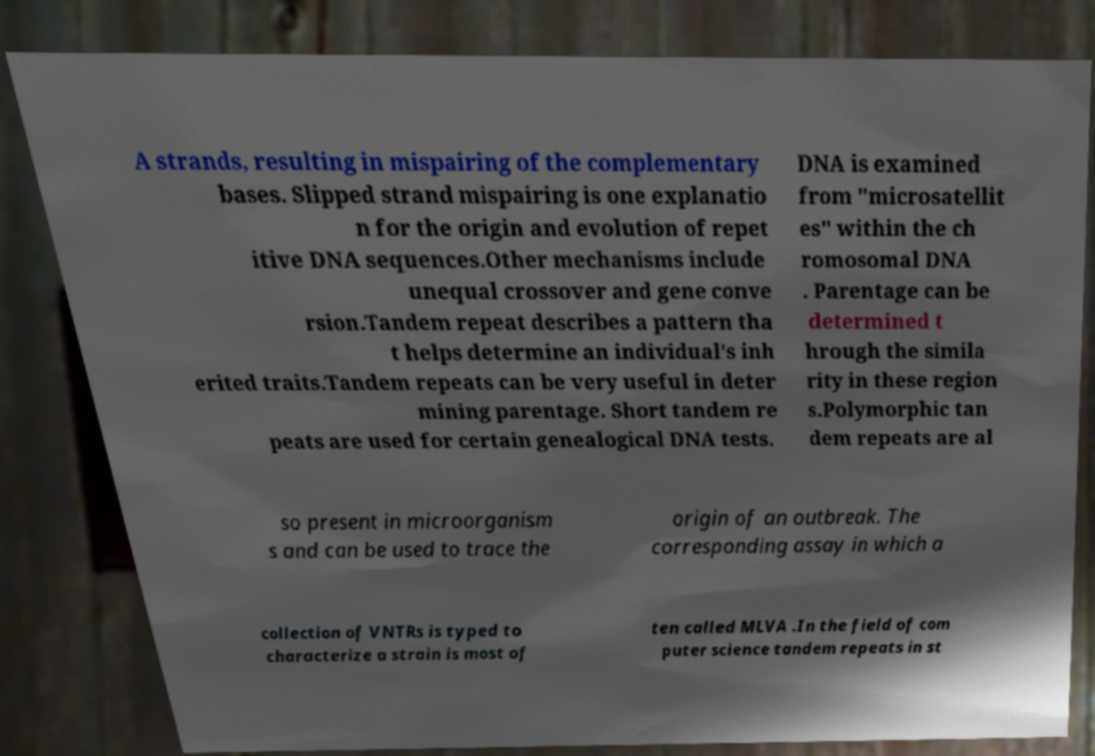Could you extract and type out the text from this image? A strands, resulting in mispairing of the complementary bases. Slipped strand mispairing is one explanatio n for the origin and evolution of repet itive DNA sequences.Other mechanisms include unequal crossover and gene conve rsion.Tandem repeat describes a pattern tha t helps determine an individual's inh erited traits.Tandem repeats can be very useful in deter mining parentage. Short tandem re peats are used for certain genealogical DNA tests. DNA is examined from "microsatellit es" within the ch romosomal DNA . Parentage can be determined t hrough the simila rity in these region s.Polymorphic tan dem repeats are al so present in microorganism s and can be used to trace the origin of an outbreak. The corresponding assay in which a collection of VNTRs is typed to characterize a strain is most of ten called MLVA .In the field of com puter science tandem repeats in st 